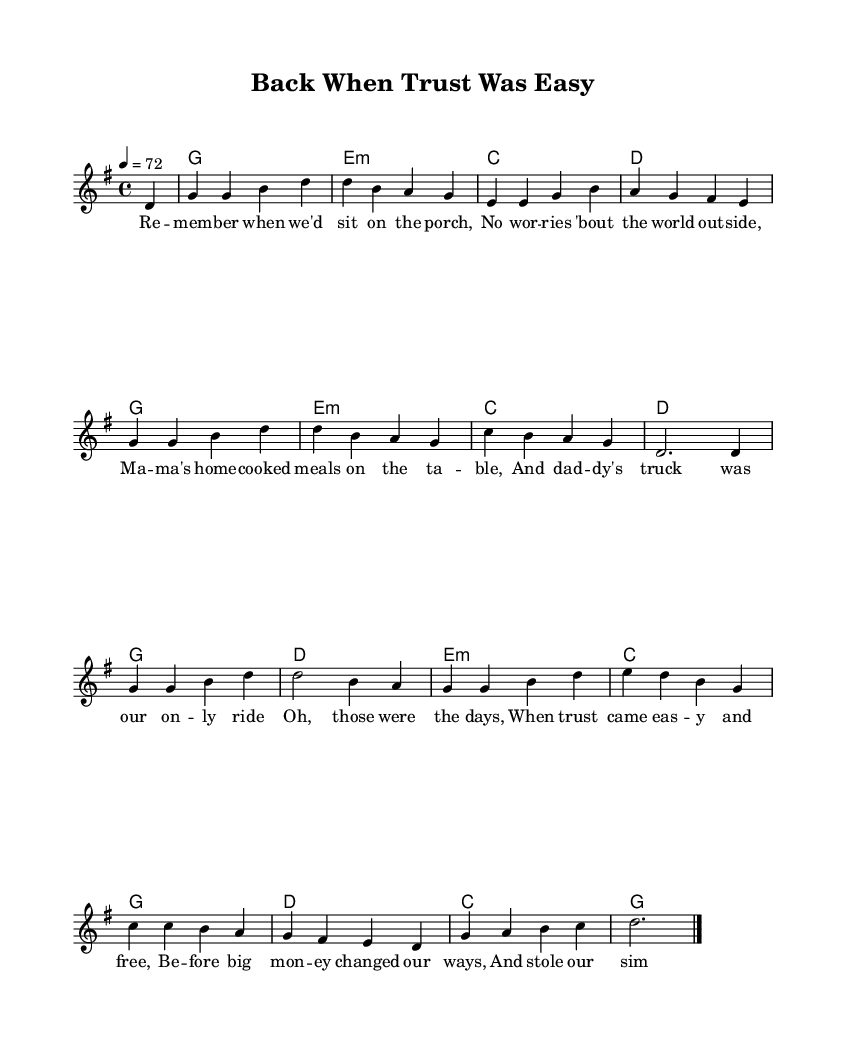What is the key signature of this music? The key signature is G major, which has one sharp (F#). This can be identified by looking at the key signature symbol at the beginning of the staff.
Answer: G major What is the time signature of this piece? The time signature is 4/4, indicated at the beginning of the score. This means there are four beats in each measure, with each beat being a quarter note.
Answer: 4/4 What is the tempo marking for this music? The tempo marking is 72 beats per minute (BPM), which is written above the staff. This indicates how fast the music should be played.
Answer: 72 How many measures are in the melody? The melody consists of 16 measures, which can be counted from the number of bar lines in the staff. Each bar line indicates the end of one measure.
Answer: 16 What emotion do the lyrics of the chorus evoke? The lyrics of the chorus evoke nostalgia and longing for the past, as they reflect on a simpler time when trust was easy and life was less complicated. The language used suggests a heartfelt reminiscence.
Answer: Nostalgia What do the lyrics suggest about the past? The lyrics suggest that the past was a time of simplicity and trust, where worries were minimal and family life was cherished, contrasting with the current corporate influences. This reflects a longing for authenticity in a changing world.
Answer: Simplicity How do the harmonies support the overall mood of the ballad? The harmonies provide a warm and comforting foundation, using common chords in country music that evoke feelings of familiarity and comfort. The progression supports the nostalgic theme of the lyrics by complementing the emotional feel of the melody.
Answer: Comforting 